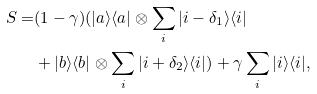Convert formula to latex. <formula><loc_0><loc_0><loc_500><loc_500>S = & ( 1 - \gamma ) ( | a \rangle \langle a | \otimes \sum _ { i } | i - \delta _ { 1 } \rangle \langle i | \\ & + | b \rangle \langle b | \otimes \sum _ { i } | i + \delta _ { 2 } \rangle \langle i | ) + \gamma \sum _ { i } | i \rangle \langle i | ,</formula> 